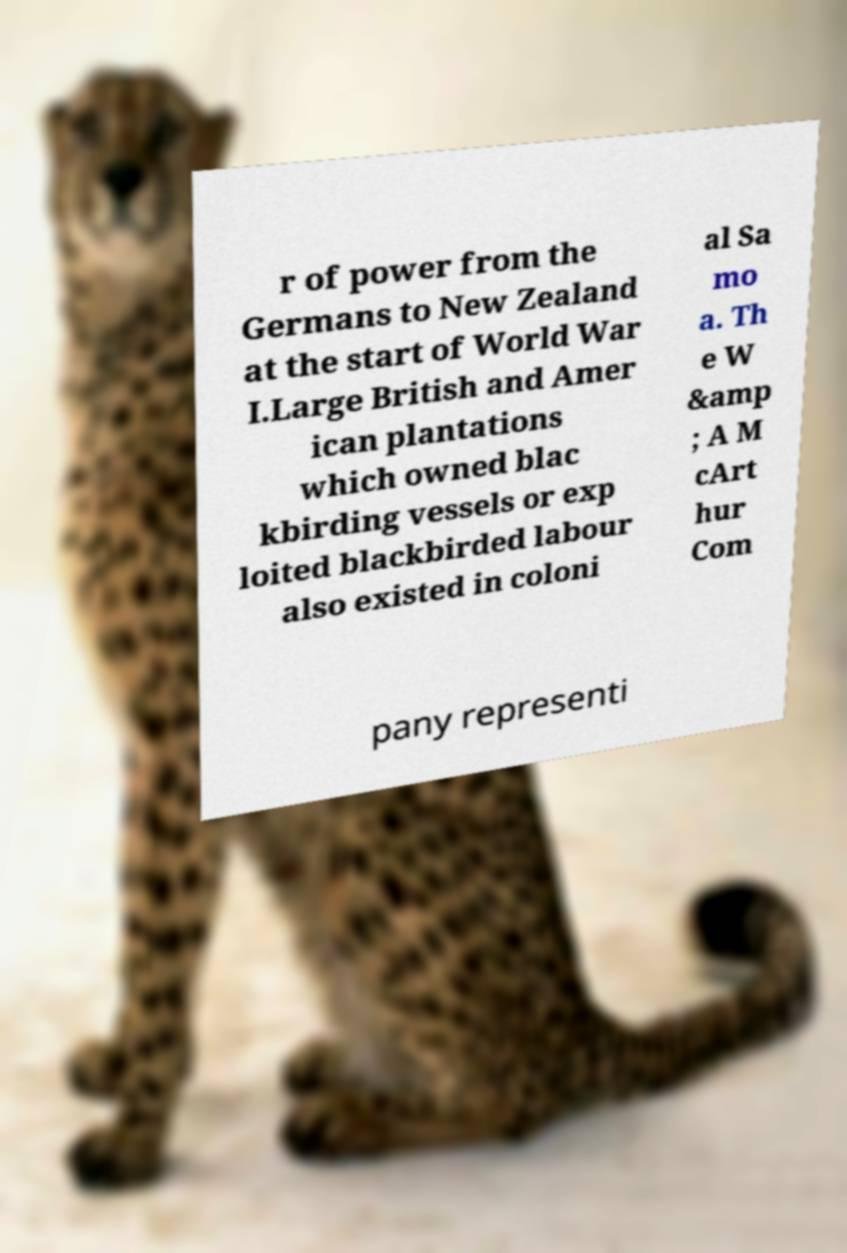Can you accurately transcribe the text from the provided image for me? r of power from the Germans to New Zealand at the start of World War I.Large British and Amer ican plantations which owned blac kbirding vessels or exp loited blackbirded labour also existed in coloni al Sa mo a. Th e W &amp ; A M cArt hur Com pany representi 